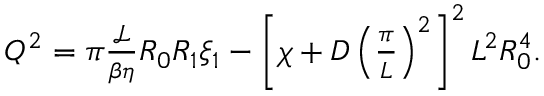Convert formula to latex. <formula><loc_0><loc_0><loc_500><loc_500>\begin{array} { r } { Q ^ { 2 } = \pi \frac { \mathcal { L } } { \beta \eta } R _ { 0 } R _ { 1 } \xi _ { 1 } - \left [ \chi + D \left ( \frac { \pi } { L } \right ) ^ { 2 } \right ] ^ { 2 } L ^ { 2 } R _ { 0 } ^ { 4 } . } \end{array}</formula> 